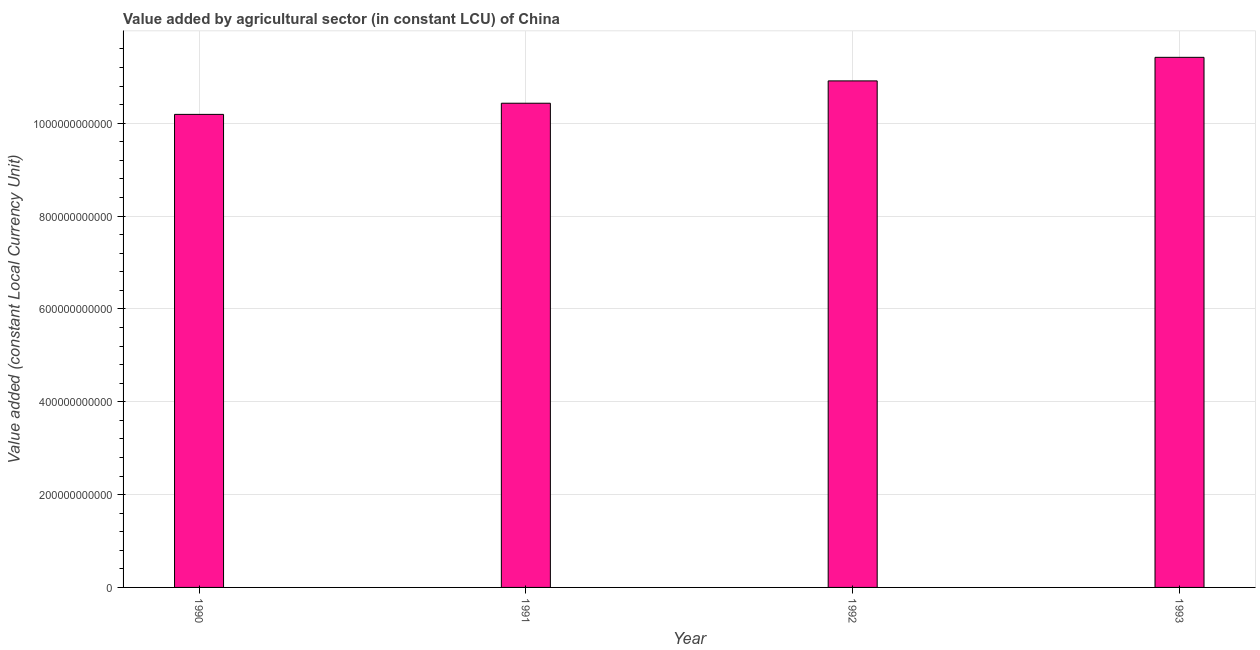Does the graph contain any zero values?
Ensure brevity in your answer.  No. Does the graph contain grids?
Your answer should be very brief. Yes. What is the title of the graph?
Provide a short and direct response. Value added by agricultural sector (in constant LCU) of China. What is the label or title of the X-axis?
Ensure brevity in your answer.  Year. What is the label or title of the Y-axis?
Your answer should be compact. Value added (constant Local Currency Unit). What is the value added by agriculture sector in 1990?
Offer a very short reply. 1.02e+12. Across all years, what is the maximum value added by agriculture sector?
Offer a terse response. 1.14e+12. Across all years, what is the minimum value added by agriculture sector?
Offer a terse response. 1.02e+12. In which year was the value added by agriculture sector maximum?
Provide a short and direct response. 1993. What is the sum of the value added by agriculture sector?
Your answer should be compact. 4.30e+12. What is the difference between the value added by agriculture sector in 1992 and 1993?
Your response must be concise. -5.08e+1. What is the average value added by agriculture sector per year?
Ensure brevity in your answer.  1.07e+12. What is the median value added by agriculture sector?
Provide a succinct answer. 1.07e+12. In how many years, is the value added by agriculture sector greater than 160000000000 LCU?
Keep it short and to the point. 4. Do a majority of the years between 1991 and 1990 (inclusive) have value added by agriculture sector greater than 200000000000 LCU?
Your response must be concise. No. What is the ratio of the value added by agriculture sector in 1991 to that in 1993?
Your answer should be very brief. 0.91. Is the difference between the value added by agriculture sector in 1990 and 1992 greater than the difference between any two years?
Keep it short and to the point. No. What is the difference between the highest and the second highest value added by agriculture sector?
Give a very brief answer. 5.08e+1. What is the difference between the highest and the lowest value added by agriculture sector?
Provide a succinct answer. 1.23e+11. How many bars are there?
Your answer should be compact. 4. How many years are there in the graph?
Provide a short and direct response. 4. What is the difference between two consecutive major ticks on the Y-axis?
Provide a succinct answer. 2.00e+11. Are the values on the major ticks of Y-axis written in scientific E-notation?
Offer a very short reply. No. What is the Value added (constant Local Currency Unit) in 1990?
Give a very brief answer. 1.02e+12. What is the Value added (constant Local Currency Unit) in 1991?
Offer a terse response. 1.04e+12. What is the Value added (constant Local Currency Unit) in 1992?
Make the answer very short. 1.09e+12. What is the Value added (constant Local Currency Unit) in 1993?
Ensure brevity in your answer.  1.14e+12. What is the difference between the Value added (constant Local Currency Unit) in 1990 and 1991?
Offer a very short reply. -2.40e+1. What is the difference between the Value added (constant Local Currency Unit) in 1990 and 1992?
Provide a succinct answer. -7.21e+1. What is the difference between the Value added (constant Local Currency Unit) in 1990 and 1993?
Keep it short and to the point. -1.23e+11. What is the difference between the Value added (constant Local Currency Unit) in 1991 and 1992?
Make the answer very short. -4.81e+1. What is the difference between the Value added (constant Local Currency Unit) in 1991 and 1993?
Give a very brief answer. -9.89e+1. What is the difference between the Value added (constant Local Currency Unit) in 1992 and 1993?
Keep it short and to the point. -5.08e+1. What is the ratio of the Value added (constant Local Currency Unit) in 1990 to that in 1992?
Your response must be concise. 0.93. What is the ratio of the Value added (constant Local Currency Unit) in 1990 to that in 1993?
Give a very brief answer. 0.89. What is the ratio of the Value added (constant Local Currency Unit) in 1991 to that in 1992?
Make the answer very short. 0.96. What is the ratio of the Value added (constant Local Currency Unit) in 1992 to that in 1993?
Provide a succinct answer. 0.96. 